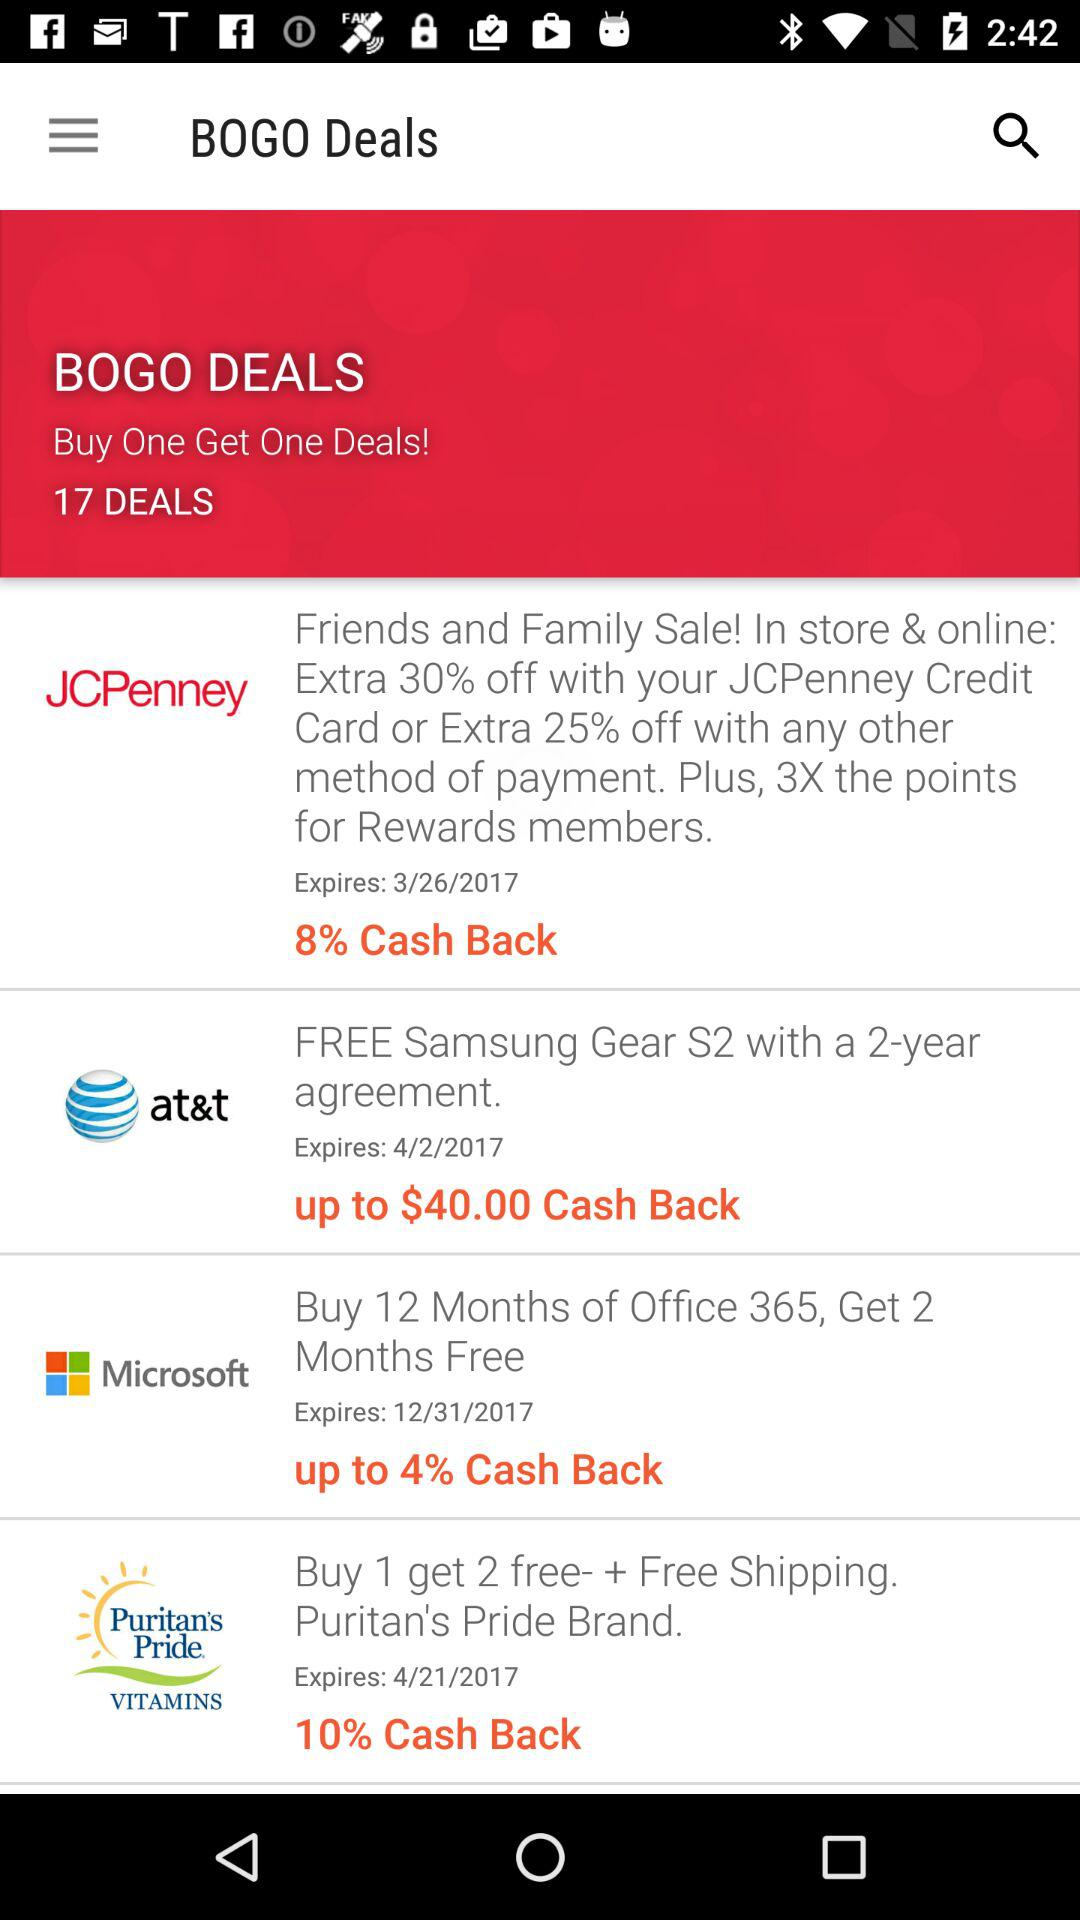What is the highest cash back percentage offered for any of the deals? The highest cash back percentage offered amongst the deals shown in the image is 10%, available on a Puritan's Pride purchase. 